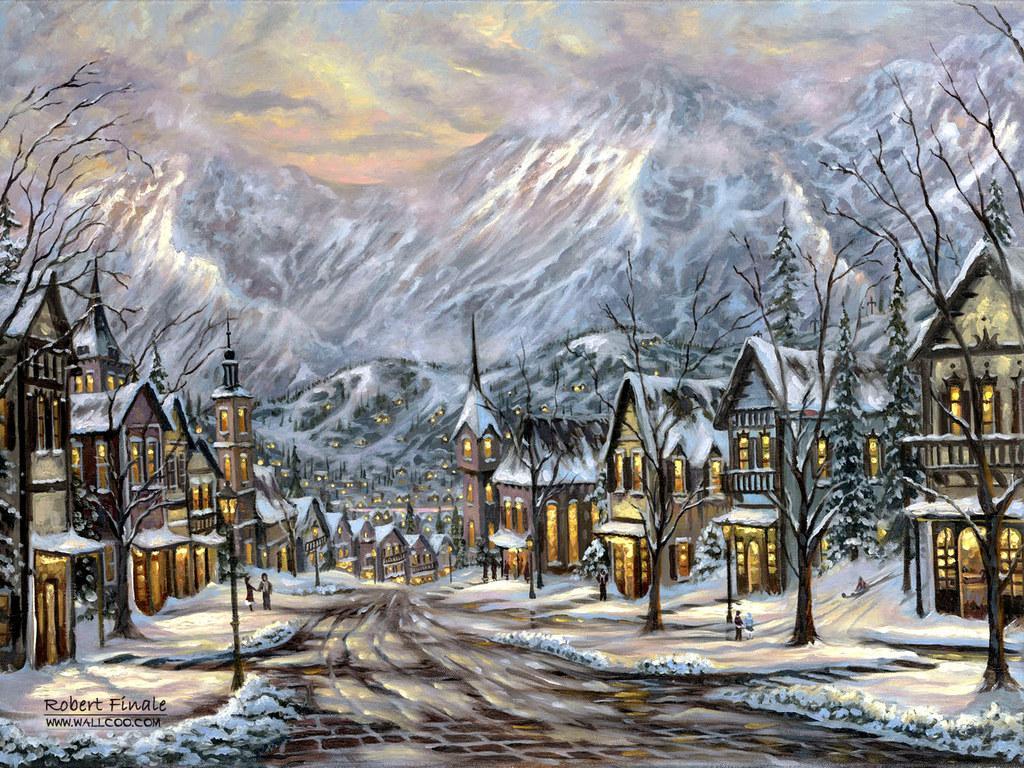Please provide a concise description of this image. It is a graphical image, in the image we can see some poles and buildings and trees and hills and clouds and sky. 